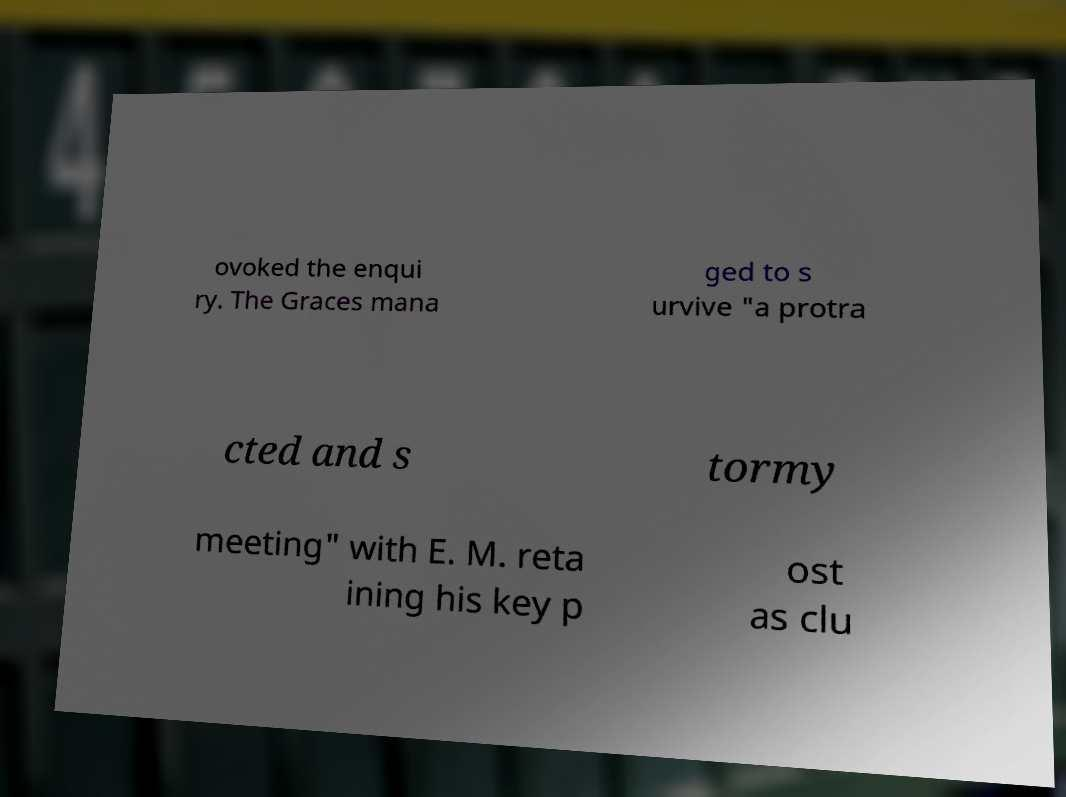I need the written content from this picture converted into text. Can you do that? ovoked the enqui ry. The Graces mana ged to s urvive "a protra cted and s tormy meeting" with E. M. reta ining his key p ost as clu 